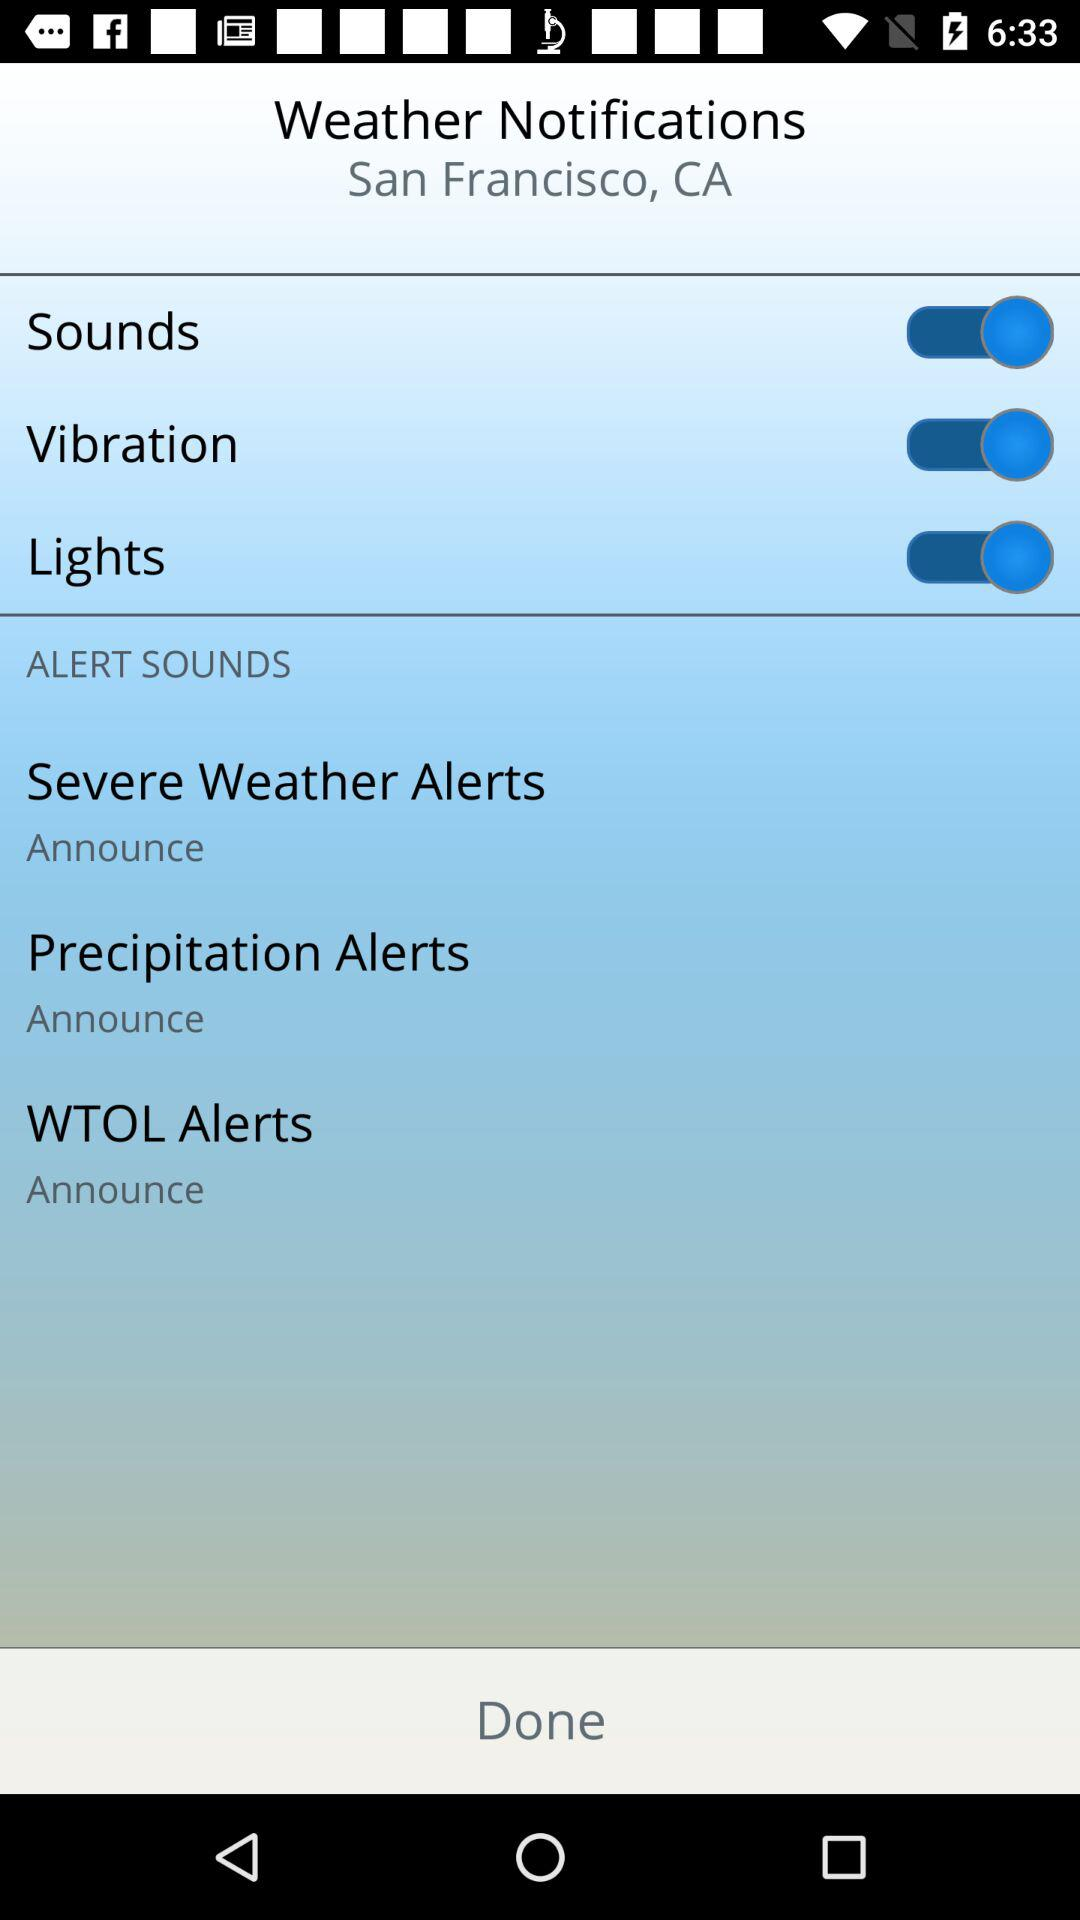For what location are the "Weather Notifications" shown? The "Weather Notifications" are shown for San Francisco, CA. 